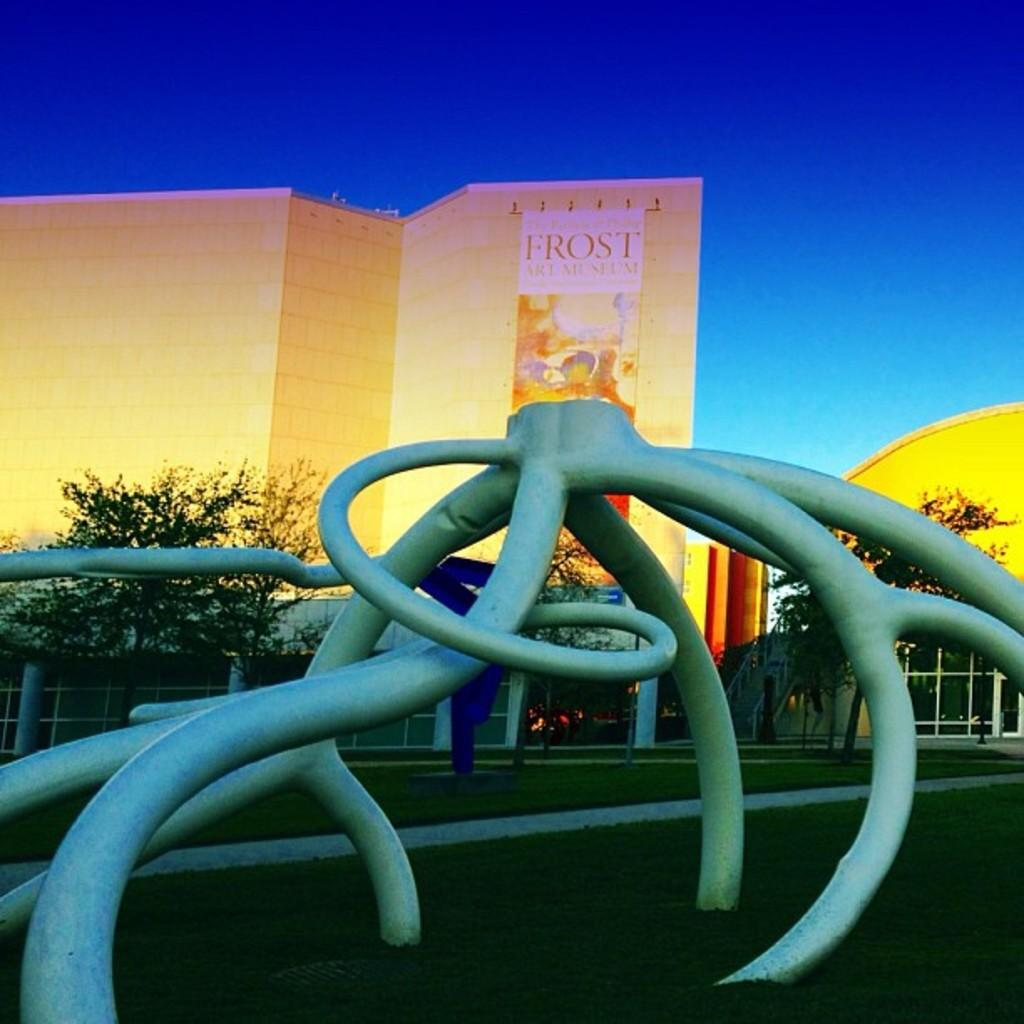What is the object on the ground in the image? The facts do not specify the object on the ground. How is the ground depicted in the image? The ground is covered in greenery. What can be seen in the background of the image? There are trees and buildings in the background. What color is the sky in the image? The sky is blue in the image. How many pears are hanging from the trees in the image? There are no pears present in the image; it only features trees and buildings in the background. 